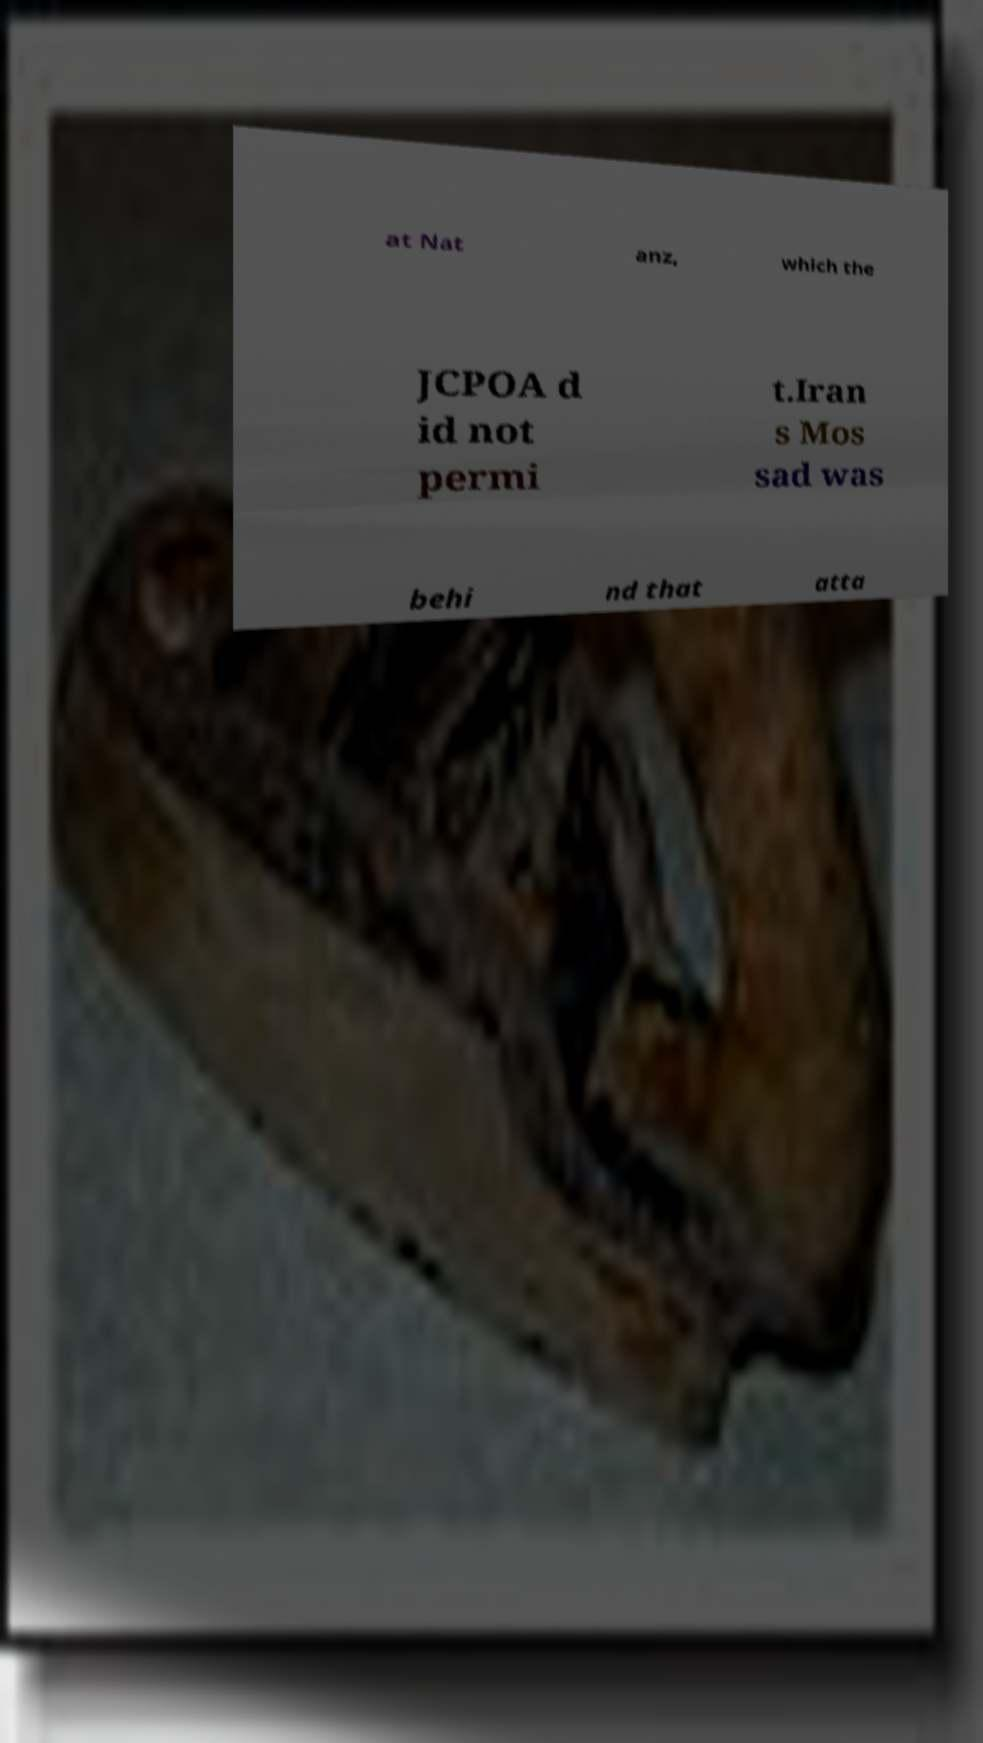Could you assist in decoding the text presented in this image and type it out clearly? at Nat anz, which the JCPOA d id not permi t.Iran s Mos sad was behi nd that atta 